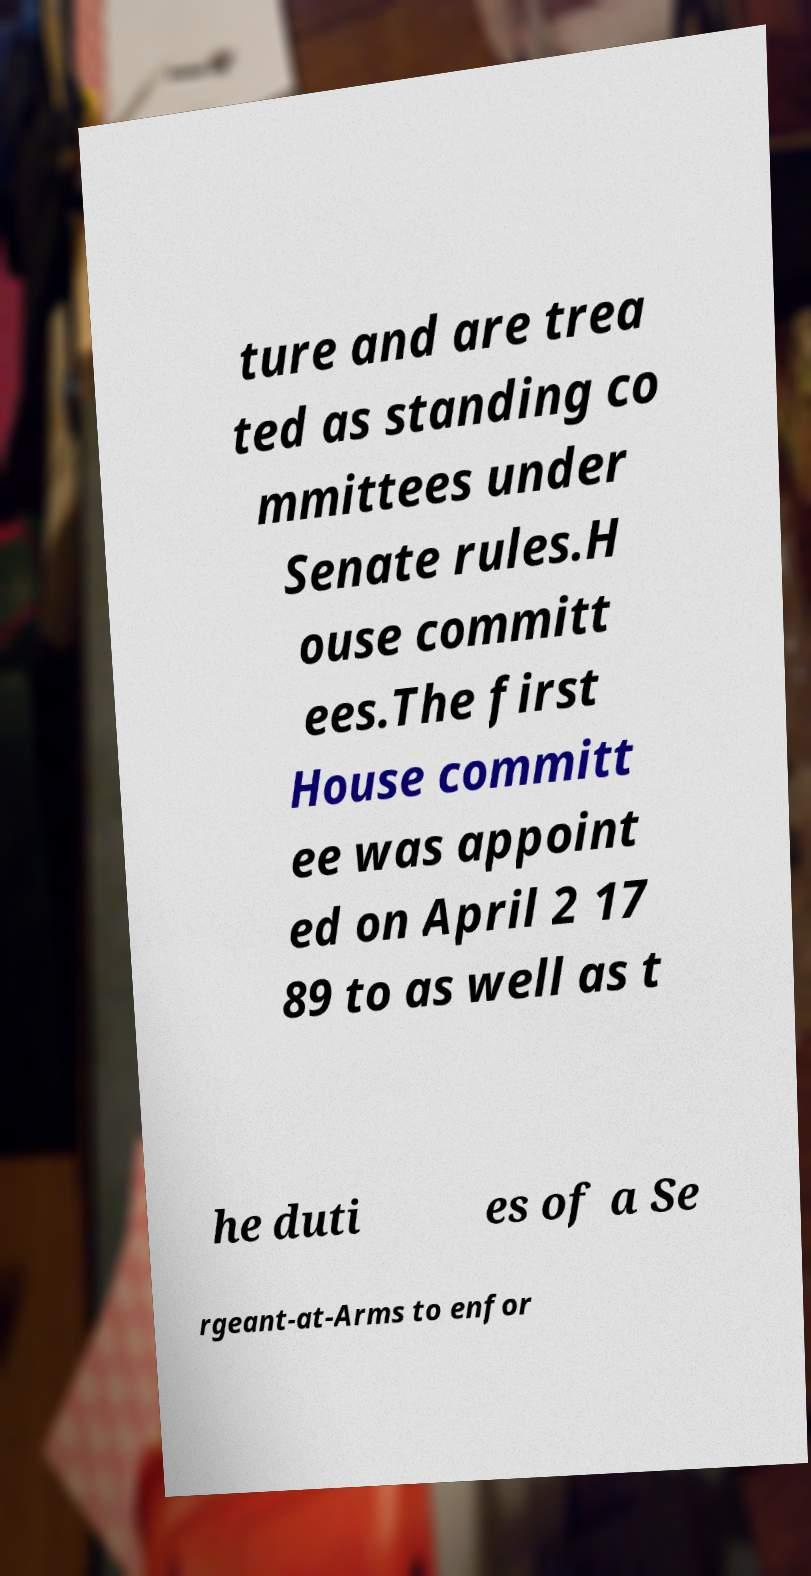What messages or text are displayed in this image? I need them in a readable, typed format. ture and are trea ted as standing co mmittees under Senate rules.H ouse committ ees.The first House committ ee was appoint ed on April 2 17 89 to as well as t he duti es of a Se rgeant-at-Arms to enfor 